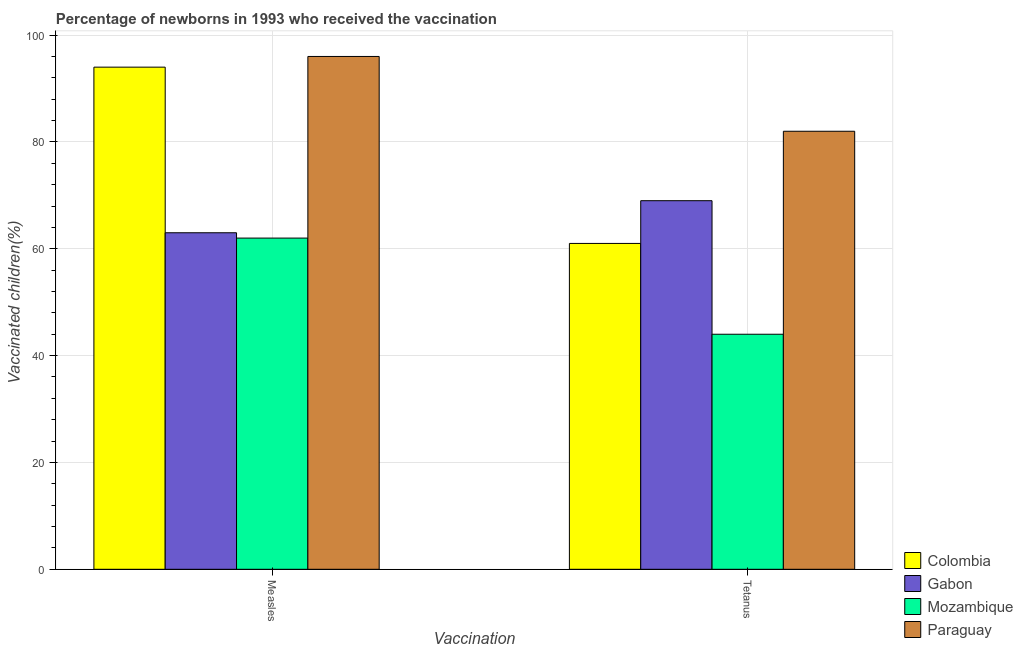How many different coloured bars are there?
Offer a very short reply. 4. How many groups of bars are there?
Give a very brief answer. 2. Are the number of bars per tick equal to the number of legend labels?
Offer a very short reply. Yes. Are the number of bars on each tick of the X-axis equal?
Make the answer very short. Yes. How many bars are there on the 1st tick from the left?
Offer a very short reply. 4. How many bars are there on the 1st tick from the right?
Your response must be concise. 4. What is the label of the 1st group of bars from the left?
Make the answer very short. Measles. What is the percentage of newborns who received vaccination for measles in Paraguay?
Give a very brief answer. 96. Across all countries, what is the maximum percentage of newborns who received vaccination for measles?
Your answer should be very brief. 96. Across all countries, what is the minimum percentage of newborns who received vaccination for tetanus?
Make the answer very short. 44. In which country was the percentage of newborns who received vaccination for measles maximum?
Ensure brevity in your answer.  Paraguay. In which country was the percentage of newborns who received vaccination for tetanus minimum?
Ensure brevity in your answer.  Mozambique. What is the total percentage of newborns who received vaccination for measles in the graph?
Ensure brevity in your answer.  315. What is the difference between the percentage of newborns who received vaccination for measles in Gabon and that in Paraguay?
Keep it short and to the point. -33. What is the difference between the percentage of newborns who received vaccination for tetanus in Mozambique and the percentage of newborns who received vaccination for measles in Gabon?
Give a very brief answer. -19. What is the average percentage of newborns who received vaccination for measles per country?
Make the answer very short. 78.75. What is the difference between the percentage of newborns who received vaccination for measles and percentage of newborns who received vaccination for tetanus in Colombia?
Provide a short and direct response. 33. In how many countries, is the percentage of newborns who received vaccination for measles greater than 80 %?
Provide a succinct answer. 2. What is the ratio of the percentage of newborns who received vaccination for measles in Gabon to that in Mozambique?
Your answer should be compact. 1.02. Is the percentage of newborns who received vaccination for measles in Mozambique less than that in Gabon?
Your answer should be very brief. Yes. In how many countries, is the percentage of newborns who received vaccination for tetanus greater than the average percentage of newborns who received vaccination for tetanus taken over all countries?
Your answer should be very brief. 2. What does the 2nd bar from the left in Tetanus represents?
Your answer should be very brief. Gabon. What does the 4th bar from the right in Measles represents?
Keep it short and to the point. Colombia. How many countries are there in the graph?
Ensure brevity in your answer.  4. What is the difference between two consecutive major ticks on the Y-axis?
Provide a succinct answer. 20. Does the graph contain any zero values?
Ensure brevity in your answer.  No. Does the graph contain grids?
Your answer should be compact. Yes. How many legend labels are there?
Your answer should be compact. 4. How are the legend labels stacked?
Provide a succinct answer. Vertical. What is the title of the graph?
Give a very brief answer. Percentage of newborns in 1993 who received the vaccination. What is the label or title of the X-axis?
Offer a terse response. Vaccination. What is the label or title of the Y-axis?
Provide a short and direct response. Vaccinated children(%)
. What is the Vaccinated children(%)
 of Colombia in Measles?
Your answer should be compact. 94. What is the Vaccinated children(%)
 of Paraguay in Measles?
Ensure brevity in your answer.  96. What is the Vaccinated children(%)
 of Colombia in Tetanus?
Provide a succinct answer. 61. What is the Vaccinated children(%)
 of Gabon in Tetanus?
Make the answer very short. 69. Across all Vaccination, what is the maximum Vaccinated children(%)
 of Colombia?
Your answer should be very brief. 94. Across all Vaccination, what is the maximum Vaccinated children(%)
 of Mozambique?
Keep it short and to the point. 62. Across all Vaccination, what is the maximum Vaccinated children(%)
 of Paraguay?
Ensure brevity in your answer.  96. Across all Vaccination, what is the minimum Vaccinated children(%)
 in Mozambique?
Offer a very short reply. 44. What is the total Vaccinated children(%)
 of Colombia in the graph?
Keep it short and to the point. 155. What is the total Vaccinated children(%)
 in Gabon in the graph?
Your response must be concise. 132. What is the total Vaccinated children(%)
 in Mozambique in the graph?
Your answer should be very brief. 106. What is the total Vaccinated children(%)
 of Paraguay in the graph?
Your answer should be very brief. 178. What is the difference between the Vaccinated children(%)
 of Gabon in Measles and that in Tetanus?
Keep it short and to the point. -6. What is the difference between the Vaccinated children(%)
 of Mozambique in Measles and that in Tetanus?
Make the answer very short. 18. What is the difference between the Vaccinated children(%)
 in Paraguay in Measles and that in Tetanus?
Keep it short and to the point. 14. What is the difference between the Vaccinated children(%)
 in Colombia in Measles and the Vaccinated children(%)
 in Gabon in Tetanus?
Your response must be concise. 25. What is the difference between the Vaccinated children(%)
 in Gabon in Measles and the Vaccinated children(%)
 in Mozambique in Tetanus?
Provide a short and direct response. 19. What is the difference between the Vaccinated children(%)
 in Gabon in Measles and the Vaccinated children(%)
 in Paraguay in Tetanus?
Offer a terse response. -19. What is the difference between the Vaccinated children(%)
 of Mozambique in Measles and the Vaccinated children(%)
 of Paraguay in Tetanus?
Your response must be concise. -20. What is the average Vaccinated children(%)
 in Colombia per Vaccination?
Your answer should be compact. 77.5. What is the average Vaccinated children(%)
 of Gabon per Vaccination?
Provide a succinct answer. 66. What is the average Vaccinated children(%)
 of Paraguay per Vaccination?
Offer a very short reply. 89. What is the difference between the Vaccinated children(%)
 in Colombia and Vaccinated children(%)
 in Mozambique in Measles?
Your answer should be compact. 32. What is the difference between the Vaccinated children(%)
 of Colombia and Vaccinated children(%)
 of Paraguay in Measles?
Offer a terse response. -2. What is the difference between the Vaccinated children(%)
 of Gabon and Vaccinated children(%)
 of Mozambique in Measles?
Your answer should be compact. 1. What is the difference between the Vaccinated children(%)
 of Gabon and Vaccinated children(%)
 of Paraguay in Measles?
Keep it short and to the point. -33. What is the difference between the Vaccinated children(%)
 in Mozambique and Vaccinated children(%)
 in Paraguay in Measles?
Provide a succinct answer. -34. What is the difference between the Vaccinated children(%)
 in Colombia and Vaccinated children(%)
 in Gabon in Tetanus?
Your response must be concise. -8. What is the difference between the Vaccinated children(%)
 of Colombia and Vaccinated children(%)
 of Mozambique in Tetanus?
Keep it short and to the point. 17. What is the difference between the Vaccinated children(%)
 of Colombia and Vaccinated children(%)
 of Paraguay in Tetanus?
Your response must be concise. -21. What is the difference between the Vaccinated children(%)
 of Gabon and Vaccinated children(%)
 of Mozambique in Tetanus?
Ensure brevity in your answer.  25. What is the difference between the Vaccinated children(%)
 in Gabon and Vaccinated children(%)
 in Paraguay in Tetanus?
Ensure brevity in your answer.  -13. What is the difference between the Vaccinated children(%)
 of Mozambique and Vaccinated children(%)
 of Paraguay in Tetanus?
Provide a succinct answer. -38. What is the ratio of the Vaccinated children(%)
 of Colombia in Measles to that in Tetanus?
Your answer should be very brief. 1.54. What is the ratio of the Vaccinated children(%)
 of Gabon in Measles to that in Tetanus?
Provide a short and direct response. 0.91. What is the ratio of the Vaccinated children(%)
 of Mozambique in Measles to that in Tetanus?
Your answer should be very brief. 1.41. What is the ratio of the Vaccinated children(%)
 of Paraguay in Measles to that in Tetanus?
Your answer should be compact. 1.17. What is the difference between the highest and the second highest Vaccinated children(%)
 in Gabon?
Keep it short and to the point. 6. What is the difference between the highest and the lowest Vaccinated children(%)
 in Colombia?
Give a very brief answer. 33. What is the difference between the highest and the lowest Vaccinated children(%)
 in Mozambique?
Your answer should be compact. 18. What is the difference between the highest and the lowest Vaccinated children(%)
 in Paraguay?
Keep it short and to the point. 14. 